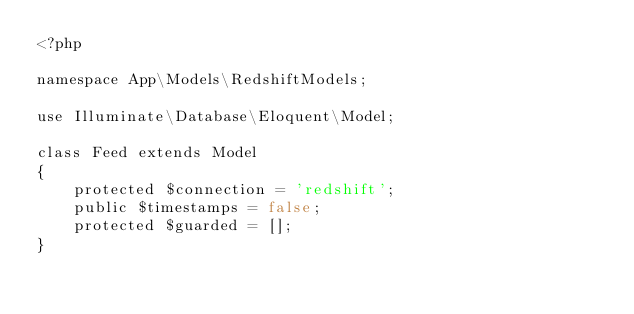Convert code to text. <code><loc_0><loc_0><loc_500><loc_500><_PHP_><?php

namespace App\Models\RedshiftModels;

use Illuminate\Database\Eloquent\Model;

class Feed extends Model
{
    protected $connection = 'redshift';
    public $timestamps = false;
    protected $guarded = [];
}</code> 